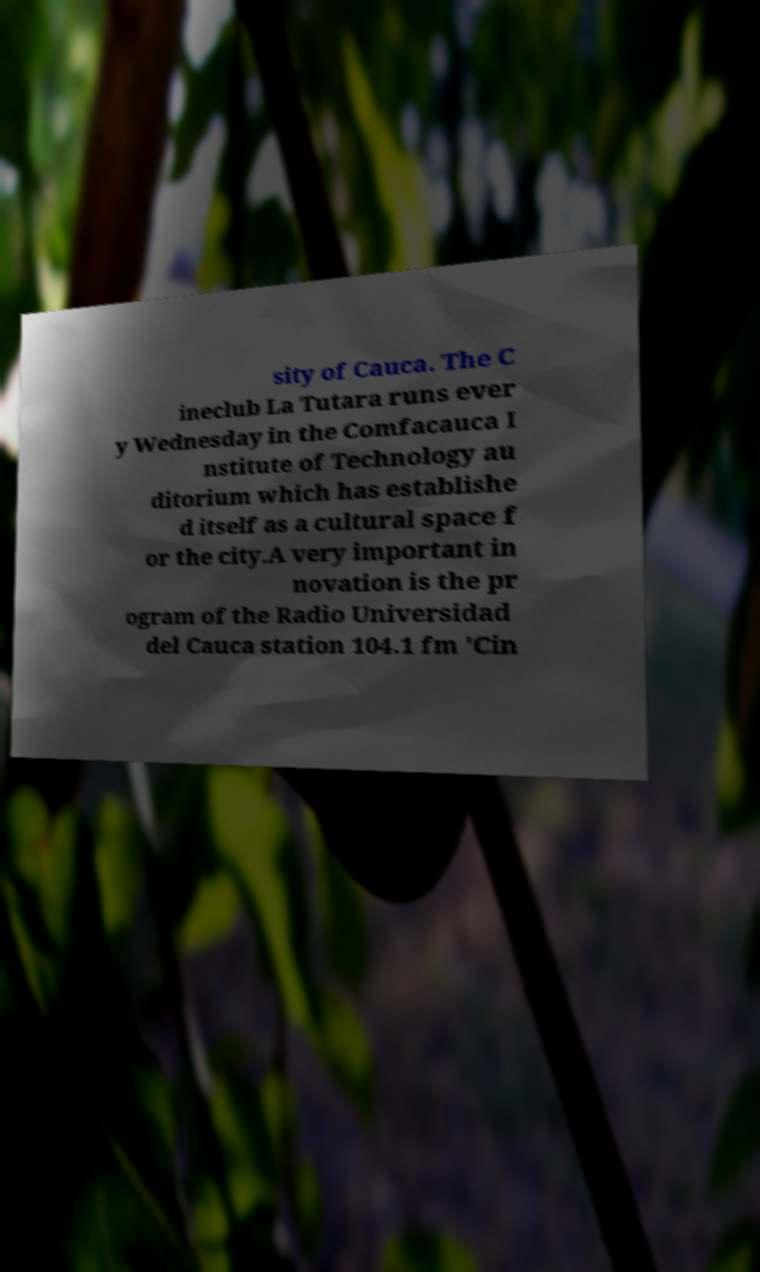Could you extract and type out the text from this image? sity of Cauca. The C ineclub La Tutara runs ever y Wednesday in the Comfacauca I nstitute of Technology au ditorium which has establishe d itself as a cultural space f or the city.A very important in novation is the pr ogram of the Radio Universidad del Cauca station 104.1 fm 'Cin 